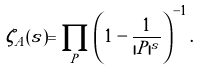<formula> <loc_0><loc_0><loc_500><loc_500>\zeta _ { A } ( s ) = \prod _ { P } \left ( 1 - \frac { 1 } { | P | ^ { s } } \right ) ^ { - 1 } .</formula> 